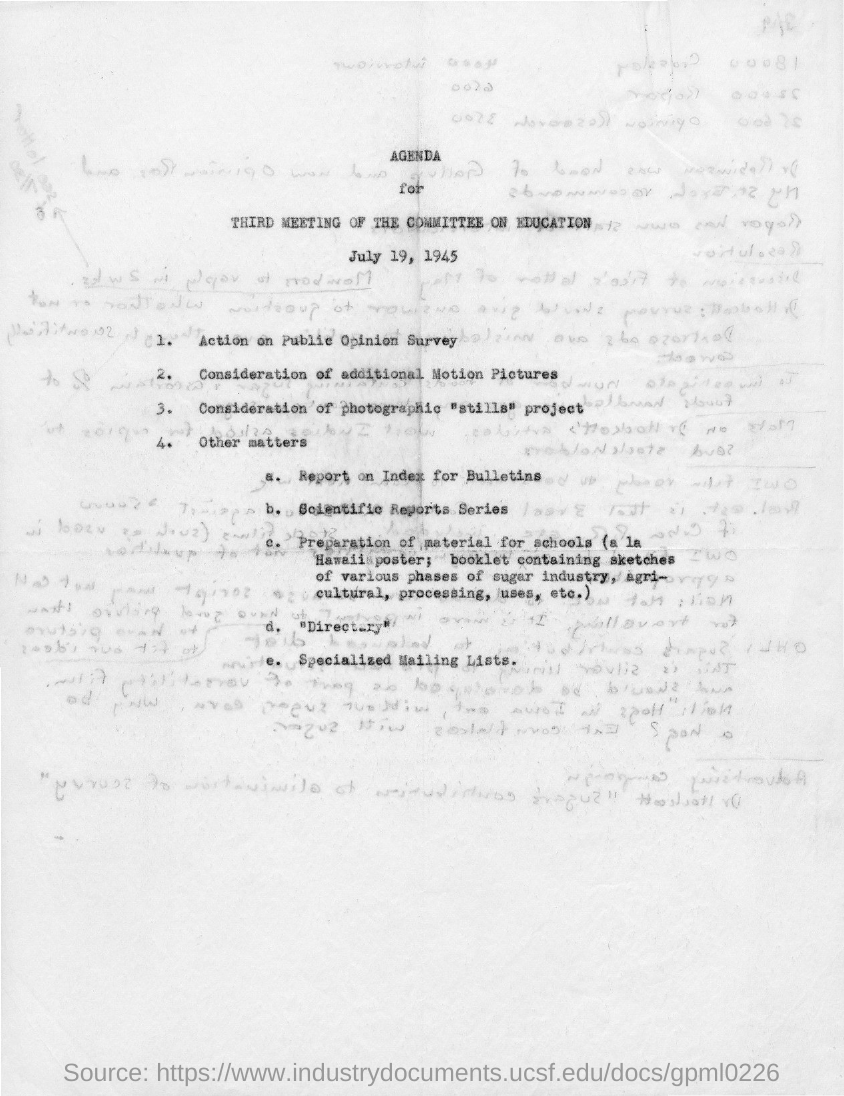What is the title of the document?
Offer a very short reply. Agenda for third meeting of the committee on education. 